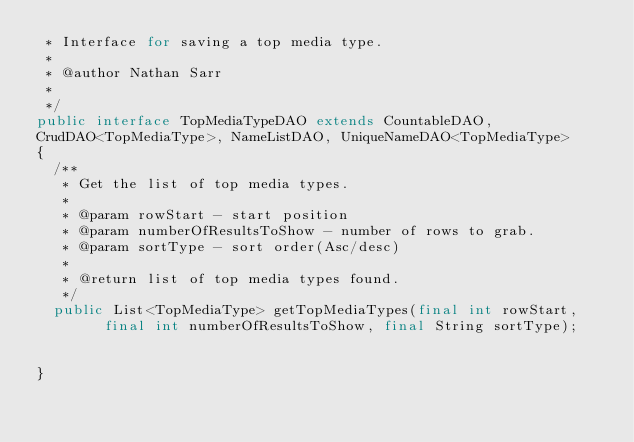<code> <loc_0><loc_0><loc_500><loc_500><_Java_> * Interface for saving a top media type.
 * 
 * @author Nathan Sarr
 *
 */
public interface TopMediaTypeDAO extends CountableDAO, 
CrudDAO<TopMediaType>, NameListDAO, UniqueNameDAO<TopMediaType>
{
	/**
	 * Get the list of top media types.
	 * 
	 * @param rowStart - start position
	 * @param numberOfResultsToShow - number of rows to grab.
	 * @param sortType - sort order(Asc/desc)
	 * 
	 * @return list of top media types found.
	 */
	public List<TopMediaType> getTopMediaTypes(final int rowStart, 
    		final int numberOfResultsToShow, final String sortType);
	
	
}
</code> 